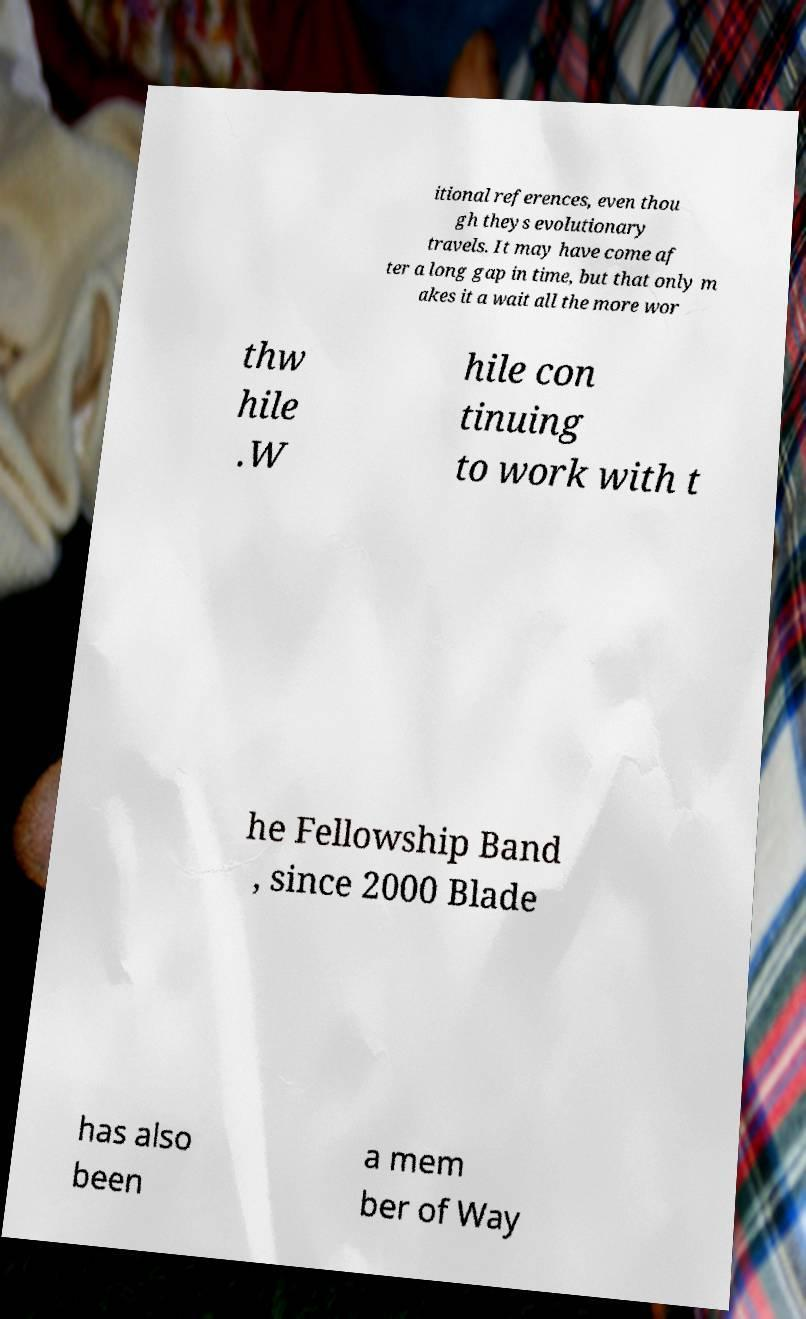I need the written content from this picture converted into text. Can you do that? itional references, even thou gh theys evolutionary travels. It may have come af ter a long gap in time, but that only m akes it a wait all the more wor thw hile .W hile con tinuing to work with t he Fellowship Band , since 2000 Blade has also been a mem ber of Way 